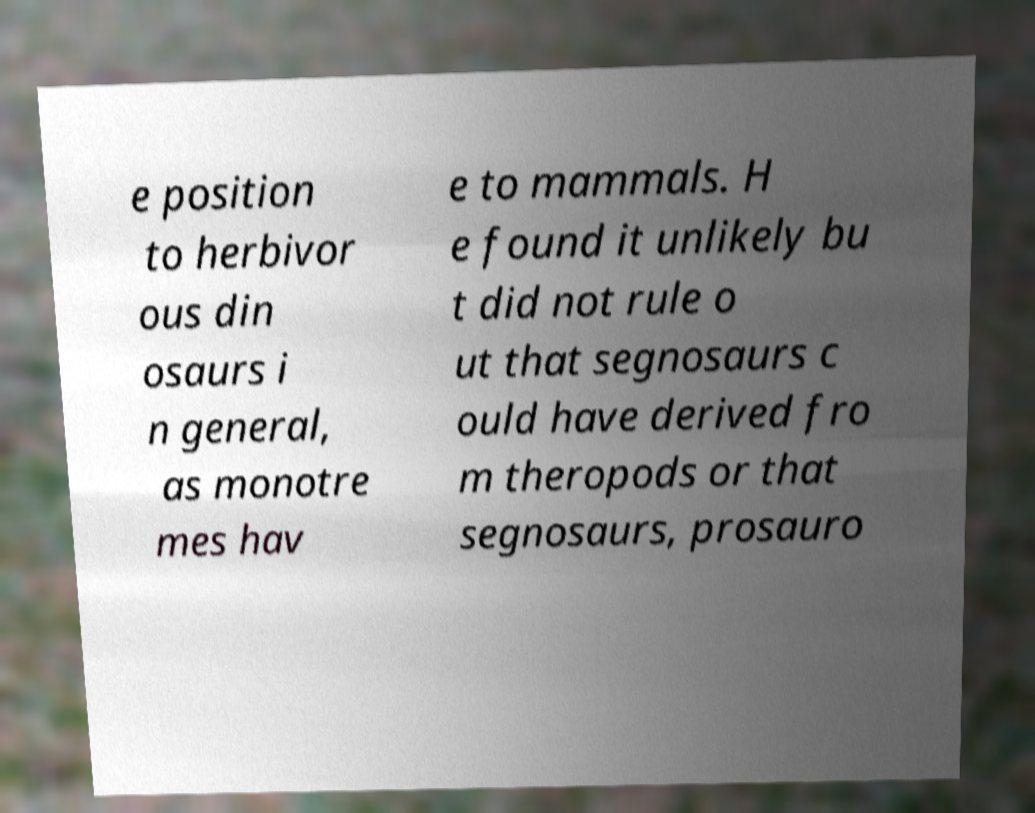Please identify and transcribe the text found in this image. e position to herbivor ous din osaurs i n general, as monotre mes hav e to mammals. H e found it unlikely bu t did not rule o ut that segnosaurs c ould have derived fro m theropods or that segnosaurs, prosauro 